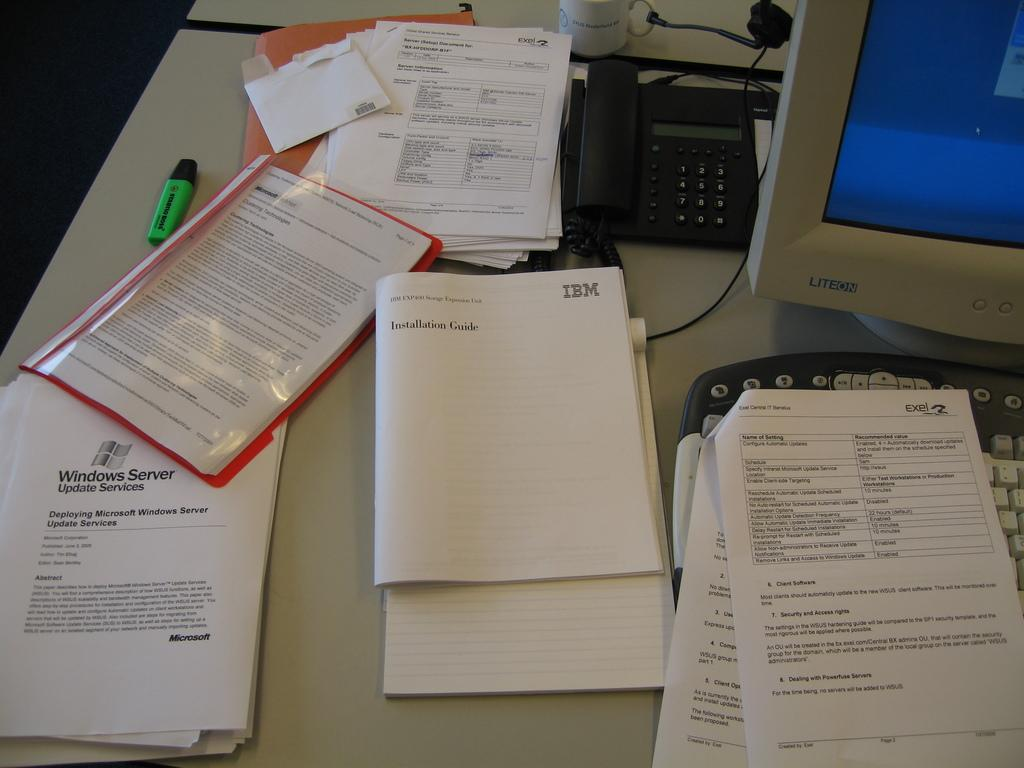<image>
Provide a brief description of the given image. a small booklet on a desk that says 'installation guide' on it 